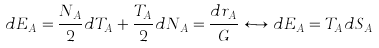Convert formula to latex. <formula><loc_0><loc_0><loc_500><loc_500>d E _ { A } = \frac { N _ { A } } { 2 } d T _ { A } + \frac { T _ { A } } { 2 } d N _ { A } = \frac { d r _ { A } } { G } \longleftrightarrow d E _ { A } = T _ { A } d S _ { A }</formula> 